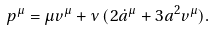<formula> <loc_0><loc_0><loc_500><loc_500>p ^ { \mu } = \mu v ^ { \mu } + \nu \, ( 2 { \dot { a } } ^ { \mu } + 3 a ^ { 2 } v ^ { \mu } ) .</formula> 